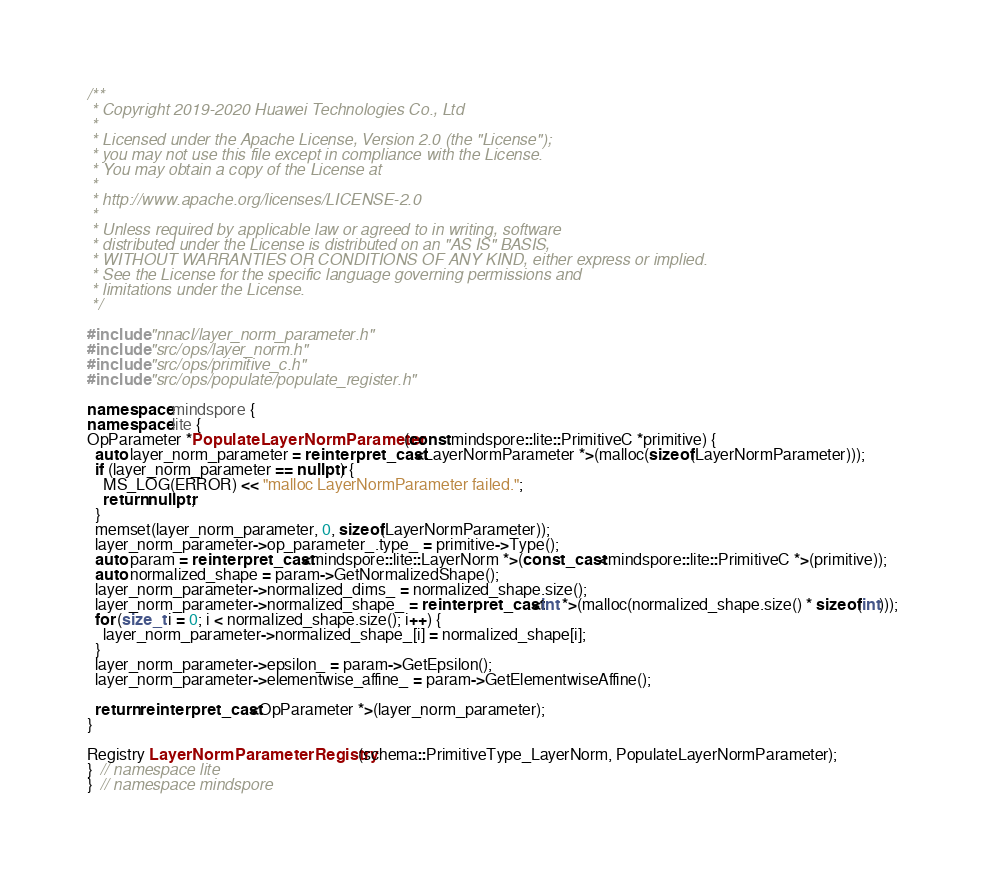Convert code to text. <code><loc_0><loc_0><loc_500><loc_500><_C++_>/**
 * Copyright 2019-2020 Huawei Technologies Co., Ltd
 *
 * Licensed under the Apache License, Version 2.0 (the "License");
 * you may not use this file except in compliance with the License.
 * You may obtain a copy of the License at
 *
 * http://www.apache.org/licenses/LICENSE-2.0
 *
 * Unless required by applicable law or agreed to in writing, software
 * distributed under the License is distributed on an "AS IS" BASIS,
 * WITHOUT WARRANTIES OR CONDITIONS OF ANY KIND, either express or implied.
 * See the License for the specific language governing permissions and
 * limitations under the License.
 */

#include "nnacl/layer_norm_parameter.h"
#include "src/ops/layer_norm.h"
#include "src/ops/primitive_c.h"
#include "src/ops/populate/populate_register.h"

namespace mindspore {
namespace lite {
OpParameter *PopulateLayerNormParameter(const mindspore::lite::PrimitiveC *primitive) {
  auto layer_norm_parameter = reinterpret_cast<LayerNormParameter *>(malloc(sizeof(LayerNormParameter)));
  if (layer_norm_parameter == nullptr) {
    MS_LOG(ERROR) << "malloc LayerNormParameter failed.";
    return nullptr;
  }
  memset(layer_norm_parameter, 0, sizeof(LayerNormParameter));
  layer_norm_parameter->op_parameter_.type_ = primitive->Type();
  auto param = reinterpret_cast<mindspore::lite::LayerNorm *>(const_cast<mindspore::lite::PrimitiveC *>(primitive));
  auto normalized_shape = param->GetNormalizedShape();
  layer_norm_parameter->normalized_dims_ = normalized_shape.size();
  layer_norm_parameter->normalized_shape_ = reinterpret_cast<int *>(malloc(normalized_shape.size() * sizeof(int)));
  for (size_t i = 0; i < normalized_shape.size(); i++) {
    layer_norm_parameter->normalized_shape_[i] = normalized_shape[i];
  }
  layer_norm_parameter->epsilon_ = param->GetEpsilon();
  layer_norm_parameter->elementwise_affine_ = param->GetElementwiseAffine();

  return reinterpret_cast<OpParameter *>(layer_norm_parameter);
}

Registry LayerNormParameterRegistry(schema::PrimitiveType_LayerNorm, PopulateLayerNormParameter);
}  // namespace lite
}  // namespace mindspore
</code> 